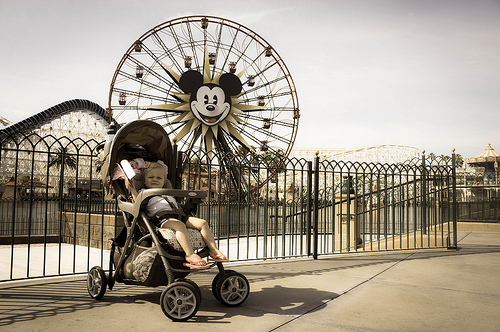<image>
Can you confirm if the baby is on the wheel chair? Yes. Looking at the image, I can see the baby is positioned on top of the wheel chair, with the wheel chair providing support. Is the ferris wheel to the right of the roller coaster? Yes. From this viewpoint, the ferris wheel is positioned to the right side relative to the roller coaster. 